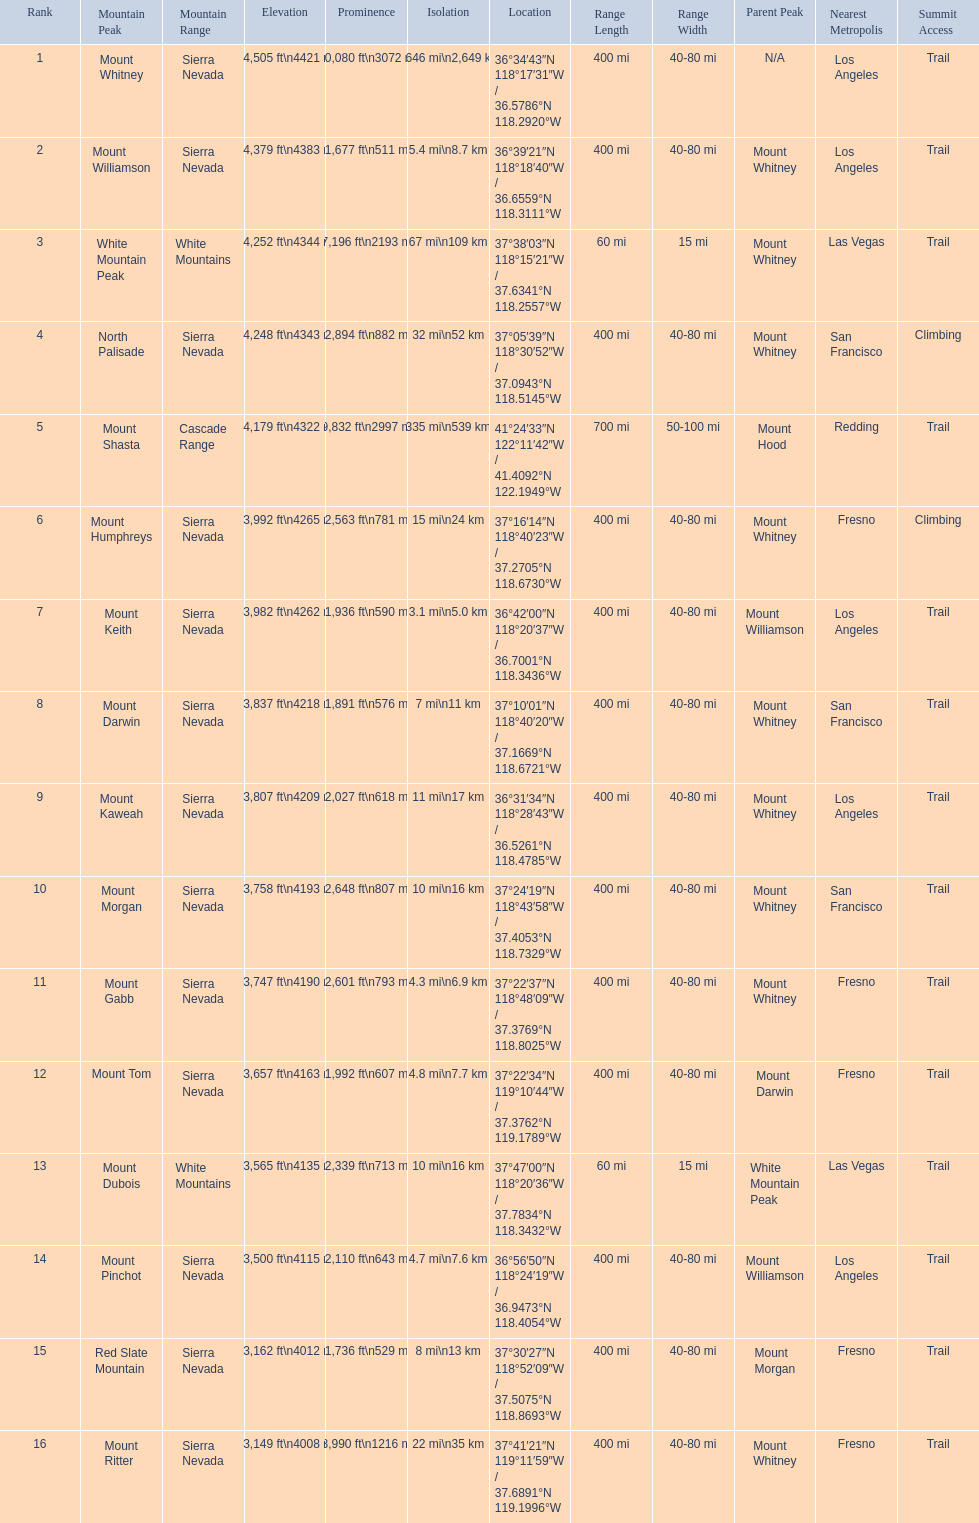What mountain peak is listed for the sierra nevada mountain range? Mount Whitney. Parse the table in full. {'header': ['Rank', 'Mountain Peak', 'Mountain Range', 'Elevation', 'Prominence', 'Isolation', 'Location', 'Range Length', 'Range Width', 'Parent Peak', 'Nearest Metropolis', 'Summit Access'], 'rows': [['1', 'Mount Whitney', 'Sierra Nevada', '14,505\xa0ft\\n4421\xa0m', '10,080\xa0ft\\n3072\xa0m', '1,646\xa0mi\\n2,649\xa0km', '36°34′43″N 118°17′31″W\ufeff / \ufeff36.5786°N 118.2920°W', '400 mi', '40-80 mi', 'N/A', 'Los Angeles', 'Trail'], ['2', 'Mount Williamson', 'Sierra Nevada', '14,379\xa0ft\\n4383\xa0m', '1,677\xa0ft\\n511\xa0m', '5.4\xa0mi\\n8.7\xa0km', '36°39′21″N 118°18′40″W\ufeff / \ufeff36.6559°N 118.3111°W', '400 mi', '40-80 mi', 'Mount Whitney', 'Los Angeles', 'Trail'], ['3', 'White Mountain Peak', 'White Mountains', '14,252\xa0ft\\n4344\xa0m', '7,196\xa0ft\\n2193\xa0m', '67\xa0mi\\n109\xa0km', '37°38′03″N 118°15′21″W\ufeff / \ufeff37.6341°N 118.2557°W', '60 mi', '15 mi', 'Mount Whitney', 'Las Vegas', 'Trail'], ['4', 'North Palisade', 'Sierra Nevada', '14,248\xa0ft\\n4343\xa0m', '2,894\xa0ft\\n882\xa0m', '32\xa0mi\\n52\xa0km', '37°05′39″N 118°30′52″W\ufeff / \ufeff37.0943°N 118.5145°W', '400 mi', '40-80 mi', 'Mount Whitney', 'San Francisco', 'Climbing'], ['5', 'Mount Shasta', 'Cascade Range', '14,179\xa0ft\\n4322\xa0m', '9,832\xa0ft\\n2997\xa0m', '335\xa0mi\\n539\xa0km', '41°24′33″N 122°11′42″W\ufeff / \ufeff41.4092°N 122.1949°W', '700 mi', '50-100 mi', 'Mount Hood', 'Redding', 'Trail'], ['6', 'Mount Humphreys', 'Sierra Nevada', '13,992\xa0ft\\n4265\xa0m', '2,563\xa0ft\\n781\xa0m', '15\xa0mi\\n24\xa0km', '37°16′14″N 118°40′23″W\ufeff / \ufeff37.2705°N 118.6730°W', '400 mi', '40-80 mi', 'Mount Whitney', 'Fresno', 'Climbing'], ['7', 'Mount Keith', 'Sierra Nevada', '13,982\xa0ft\\n4262\xa0m', '1,936\xa0ft\\n590\xa0m', '3.1\xa0mi\\n5.0\xa0km', '36°42′00″N 118°20′37″W\ufeff / \ufeff36.7001°N 118.3436°W', '400 mi', '40-80 mi', 'Mount Williamson', 'Los Angeles', 'Trail'], ['8', 'Mount Darwin', 'Sierra Nevada', '13,837\xa0ft\\n4218\xa0m', '1,891\xa0ft\\n576\xa0m', '7\xa0mi\\n11\xa0km', '37°10′01″N 118°40′20″W\ufeff / \ufeff37.1669°N 118.6721°W', '400 mi', '40-80 mi', 'Mount Whitney', 'San Francisco', 'Trail'], ['9', 'Mount Kaweah', 'Sierra Nevada', '13,807\xa0ft\\n4209\xa0m', '2,027\xa0ft\\n618\xa0m', '11\xa0mi\\n17\xa0km', '36°31′34″N 118°28′43″W\ufeff / \ufeff36.5261°N 118.4785°W', '400 mi', '40-80 mi', 'Mount Whitney', 'Los Angeles', 'Trail'], ['10', 'Mount Morgan', 'Sierra Nevada', '13,758\xa0ft\\n4193\xa0m', '2,648\xa0ft\\n807\xa0m', '10\xa0mi\\n16\xa0km', '37°24′19″N 118°43′58″W\ufeff / \ufeff37.4053°N 118.7329°W', '400 mi', '40-80 mi', 'Mount Whitney', 'San Francisco', 'Trail'], ['11', 'Mount Gabb', 'Sierra Nevada', '13,747\xa0ft\\n4190\xa0m', '2,601\xa0ft\\n793\xa0m', '4.3\xa0mi\\n6.9\xa0km', '37°22′37″N 118°48′09″W\ufeff / \ufeff37.3769°N 118.8025°W', '400 mi', '40-80 mi', 'Mount Whitney', 'Fresno', 'Trail'], ['12', 'Mount Tom', 'Sierra Nevada', '13,657\xa0ft\\n4163\xa0m', '1,992\xa0ft\\n607\xa0m', '4.8\xa0mi\\n7.7\xa0km', '37°22′34″N 119°10′44″W\ufeff / \ufeff37.3762°N 119.1789°W', '400 mi', '40-80 mi', 'Mount Darwin', 'Fresno', 'Trail'], ['13', 'Mount Dubois', 'White Mountains', '13,565\xa0ft\\n4135\xa0m', '2,339\xa0ft\\n713\xa0m', '10\xa0mi\\n16\xa0km', '37°47′00″N 118°20′36″W\ufeff / \ufeff37.7834°N 118.3432°W', '60 mi', '15 mi', 'White Mountain Peak', 'Las Vegas', 'Trail'], ['14', 'Mount Pinchot', 'Sierra Nevada', '13,500\xa0ft\\n4115\xa0m', '2,110\xa0ft\\n643\xa0m', '4.7\xa0mi\\n7.6\xa0km', '36°56′50″N 118°24′19″W\ufeff / \ufeff36.9473°N 118.4054°W', '400 mi', '40-80 mi', 'Mount Williamson', 'Los Angeles', 'Trail'], ['15', 'Red Slate Mountain', 'Sierra Nevada', '13,162\xa0ft\\n4012\xa0m', '1,736\xa0ft\\n529\xa0m', '8\xa0mi\\n13\xa0km', '37°30′27″N 118°52′09″W\ufeff / \ufeff37.5075°N 118.8693°W', '400 mi', '40-80 mi', 'Mount Morgan', 'Fresno', 'Trail'], ['16', 'Mount Ritter', 'Sierra Nevada', '13,149\xa0ft\\n4008\xa0m', '3,990\xa0ft\\n1216\xa0m', '22\xa0mi\\n35\xa0km', '37°41′21″N 119°11′59″W\ufeff / \ufeff37.6891°N 119.1996°W', '400 mi', '40-80 mi', 'Mount Whitney', 'Fresno', 'Trail']]} What mountain peak has an elevation of 14,379ft? Mount Williamson. Which mountain is listed for the cascade range? Mount Shasta. 